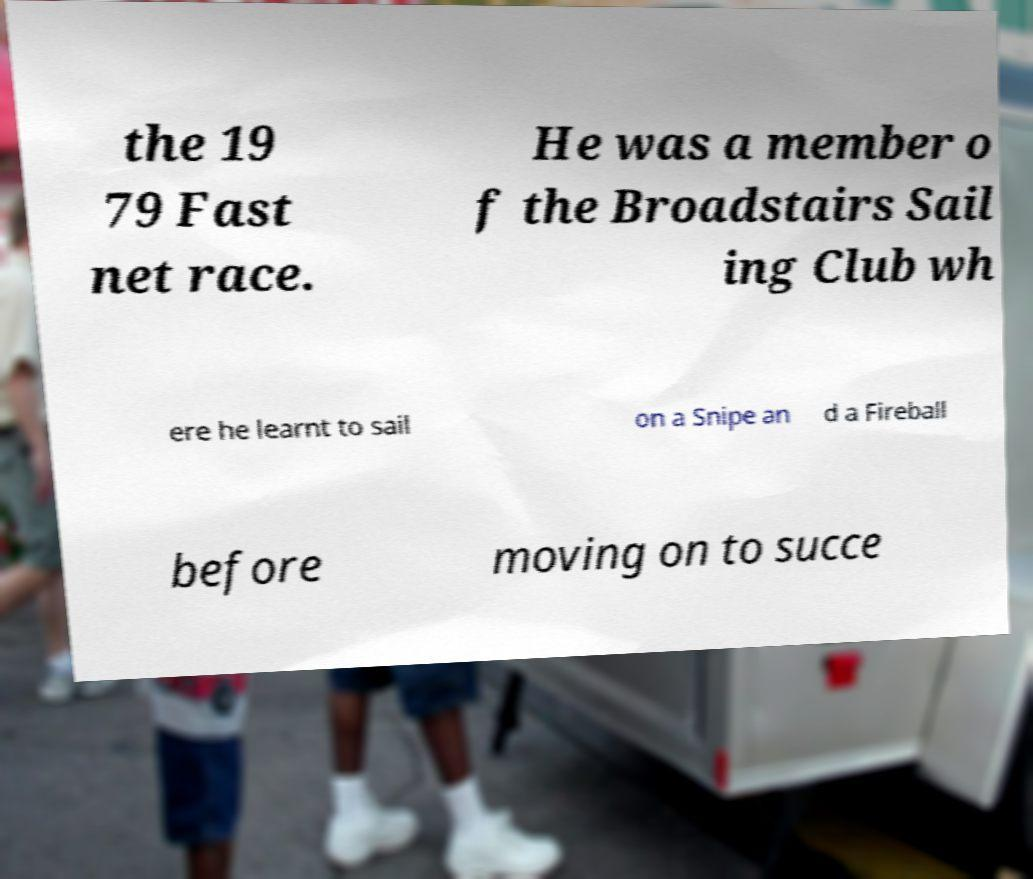I need the written content from this picture converted into text. Can you do that? the 19 79 Fast net race. He was a member o f the Broadstairs Sail ing Club wh ere he learnt to sail on a Snipe an d a Fireball before moving on to succe 